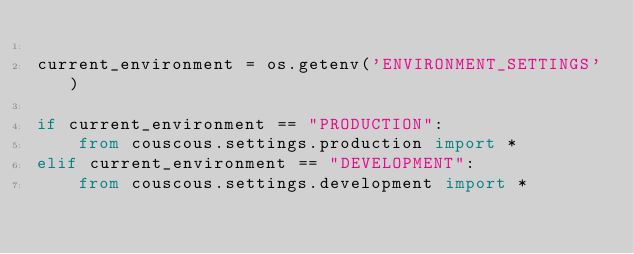<code> <loc_0><loc_0><loc_500><loc_500><_Python_>
current_environment = os.getenv('ENVIRONMENT_SETTINGS')

if current_environment == "PRODUCTION":
    from couscous.settings.production import *
elif current_environment == "DEVELOPMENT":
    from couscous.settings.development import *
</code> 